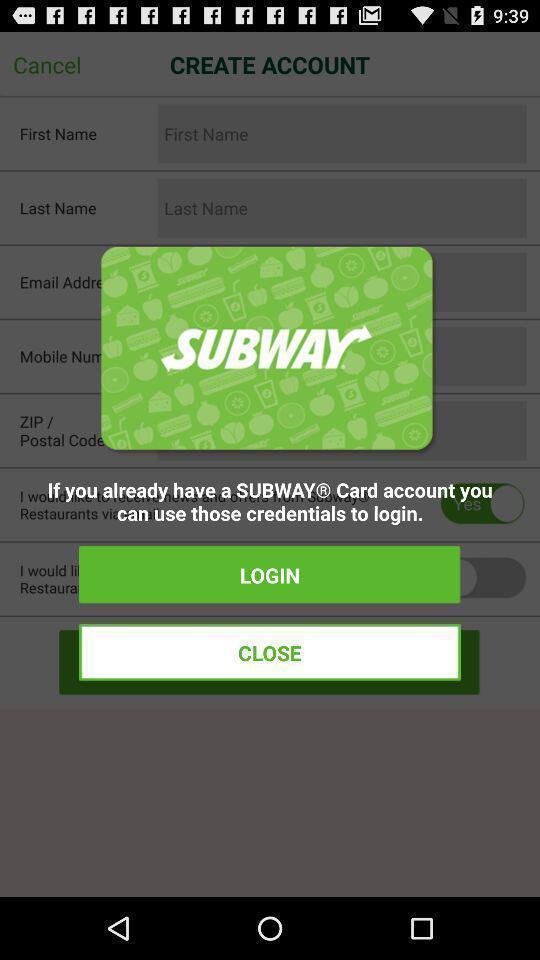Summarize the information in this screenshot. Pop-up showing login options for a food related app. 